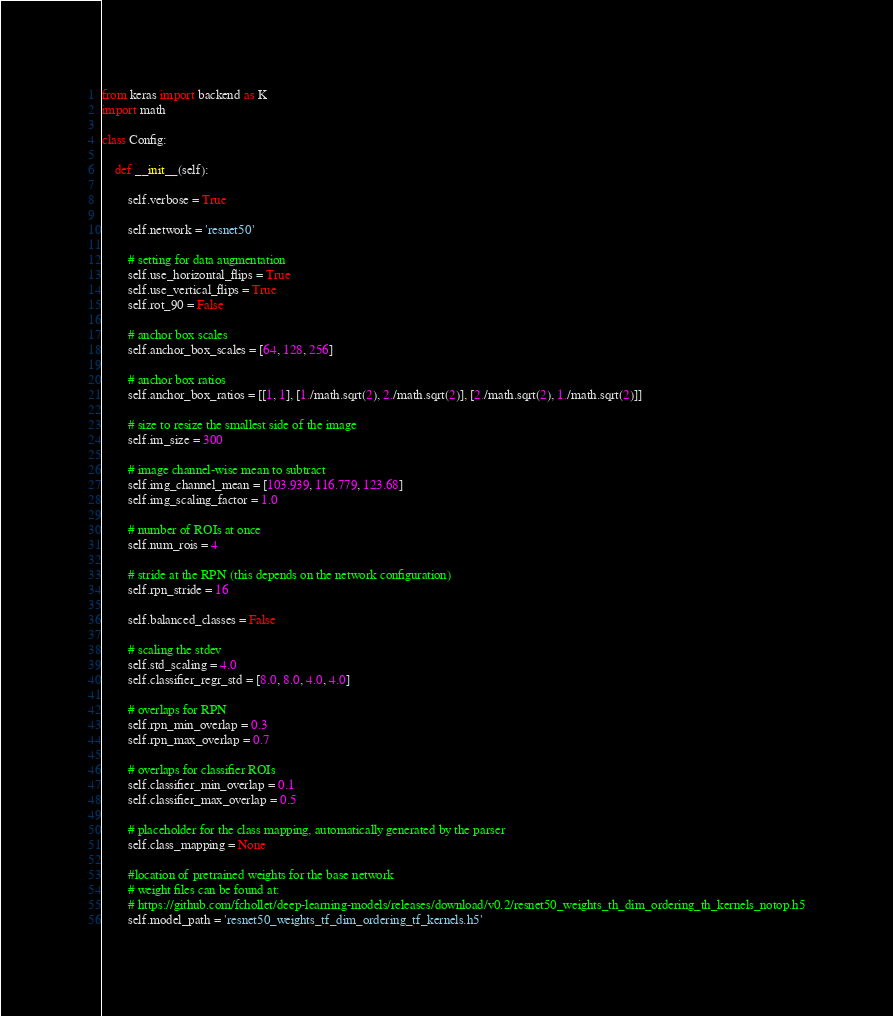Convert code to text. <code><loc_0><loc_0><loc_500><loc_500><_Python_>from keras import backend as K
import math

class Config:

	def __init__(self):

		self.verbose = True

		self.network = 'resnet50'

		# setting for data augmentation
		self.use_horizontal_flips = True
		self.use_vertical_flips = True
		self.rot_90 = False

		# anchor box scales
		self.anchor_box_scales = [64, 128, 256]

		# anchor box ratios
		self.anchor_box_ratios = [[1, 1], [1./math.sqrt(2), 2./math.sqrt(2)], [2./math.sqrt(2), 1./math.sqrt(2)]]

		# size to resize the smallest side of the image
		self.im_size = 300

		# image channel-wise mean to subtract
		self.img_channel_mean = [103.939, 116.779, 123.68]
		self.img_scaling_factor = 1.0

		# number of ROIs at once
		self.num_rois = 4

		# stride at the RPN (this depends on the network configuration)
		self.rpn_stride = 16

		self.balanced_classes = False

		# scaling the stdev
		self.std_scaling = 4.0
		self.classifier_regr_std = [8.0, 8.0, 4.0, 4.0]

		# overlaps for RPN
		self.rpn_min_overlap = 0.3
		self.rpn_max_overlap = 0.7

		# overlaps for classifier ROIs
		self.classifier_min_overlap = 0.1
		self.classifier_max_overlap = 0.5

		# placeholder for the class mapping, automatically generated by the parser
		self.class_mapping = None

		#location of pretrained weights for the base network 
		# weight files can be found at:
		# https://github.com/fchollet/deep-learning-models/releases/download/v0.2/resnet50_weights_th_dim_ordering_th_kernels_notop.h5
		self.model_path = 'resnet50_weights_tf_dim_ordering_tf_kernels.h5'
</code> 